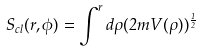Convert formula to latex. <formula><loc_0><loc_0><loc_500><loc_500>S _ { c l } ( r , \phi ) = \int ^ { r } d \rho ( 2 m V ( \rho ) ) ^ { \frac { 1 } { 2 } }</formula> 